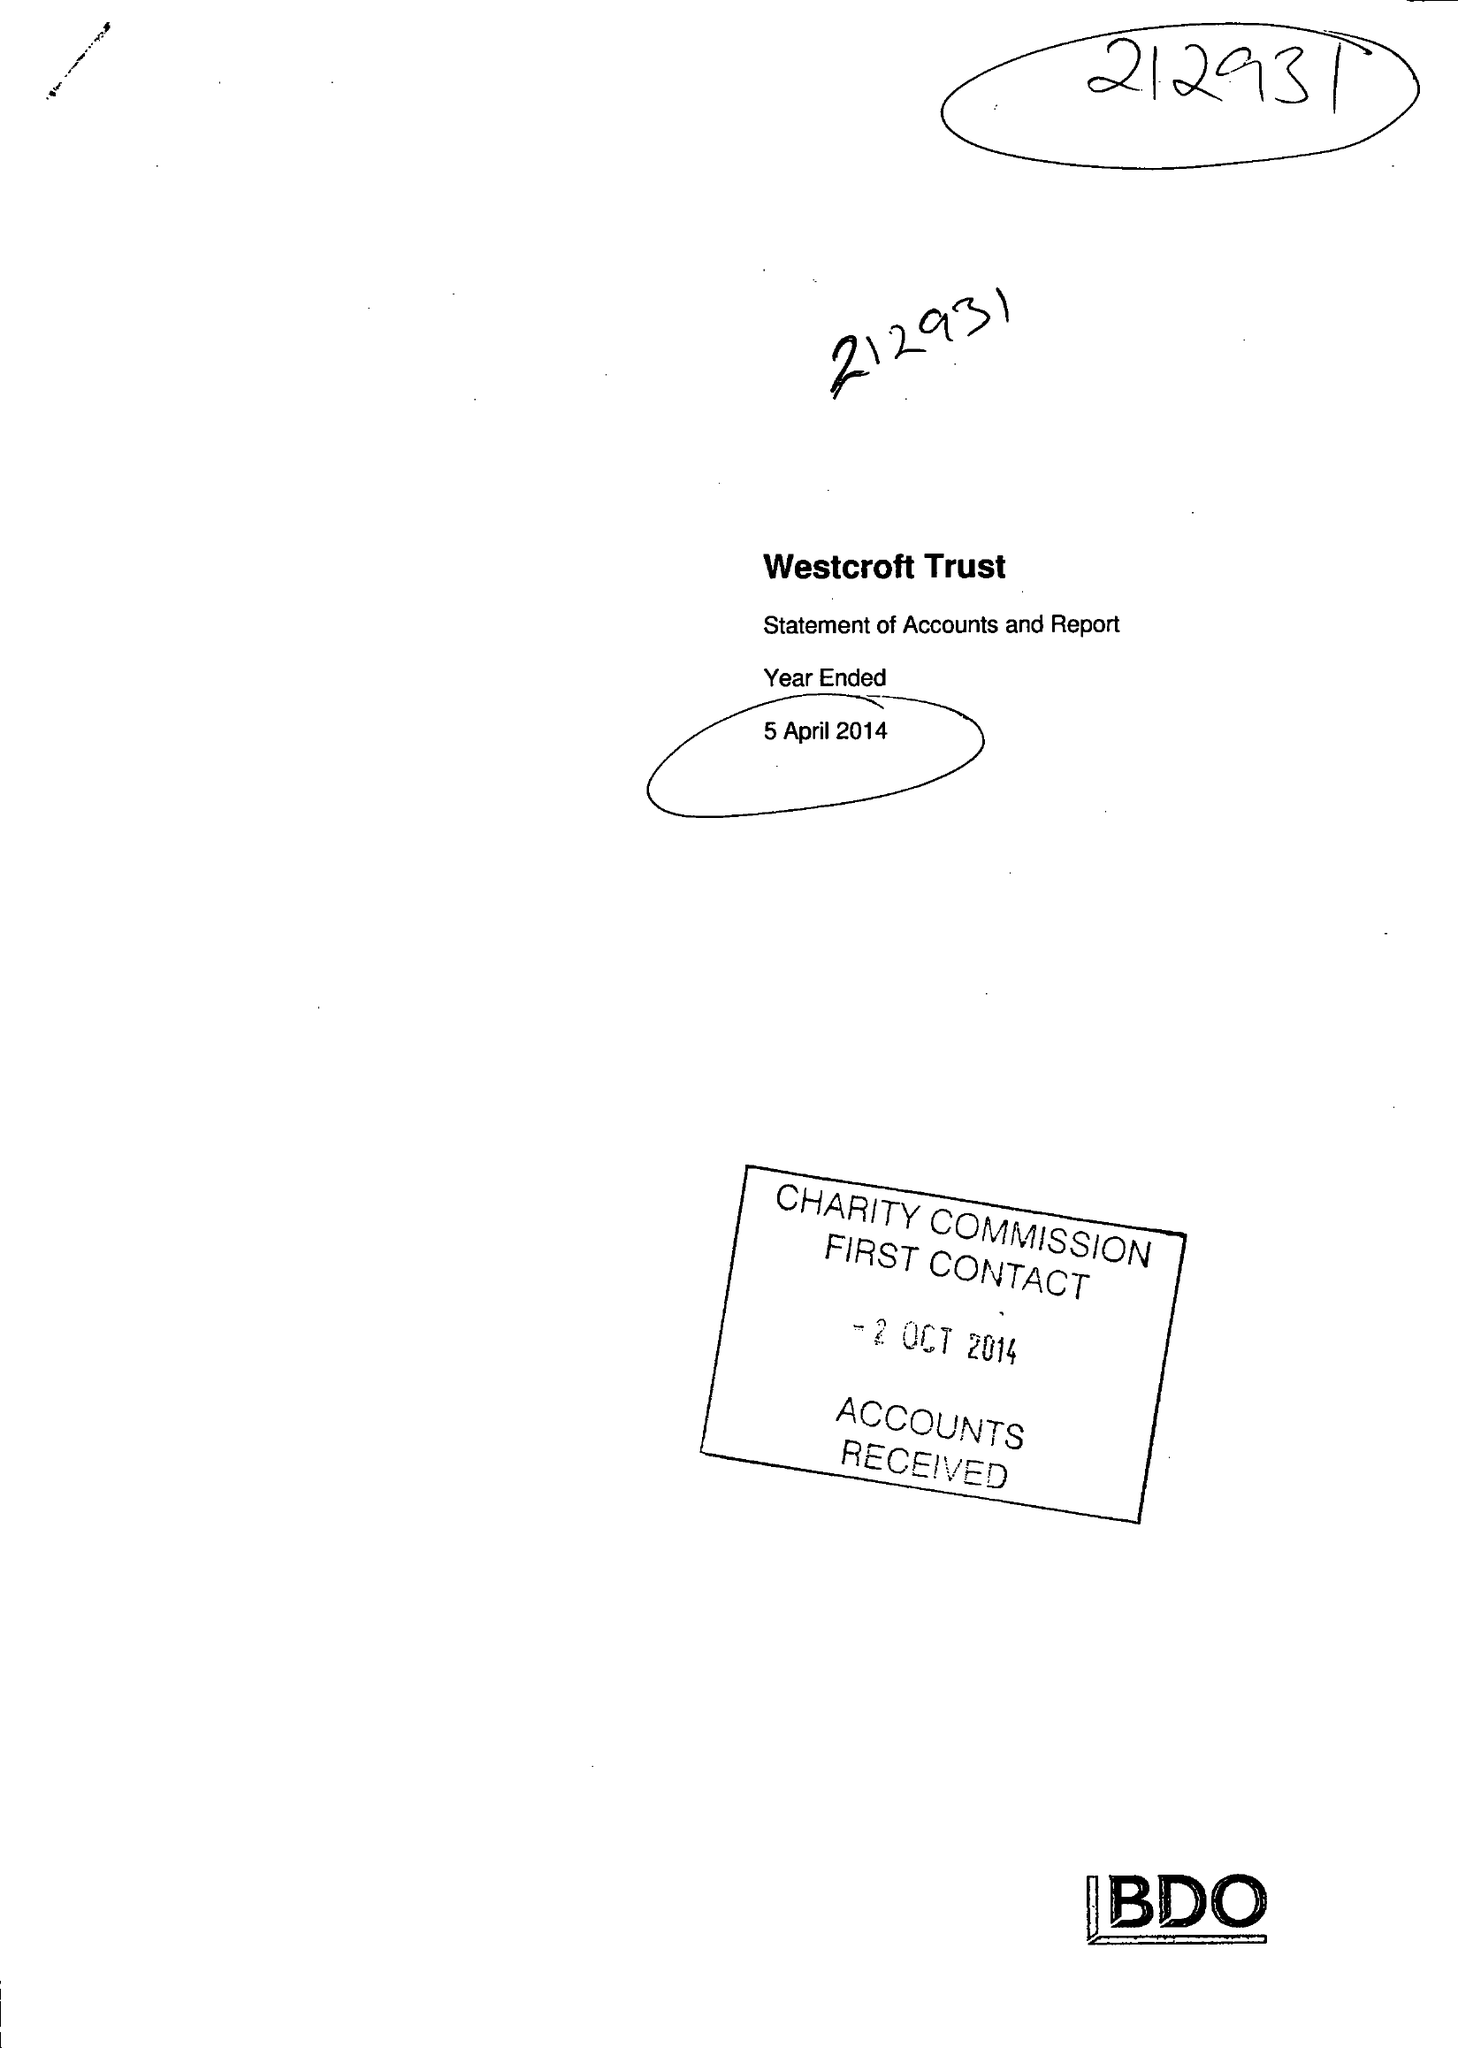What is the value for the charity_name?
Answer the question using a single word or phrase. The Westcroft Trust 